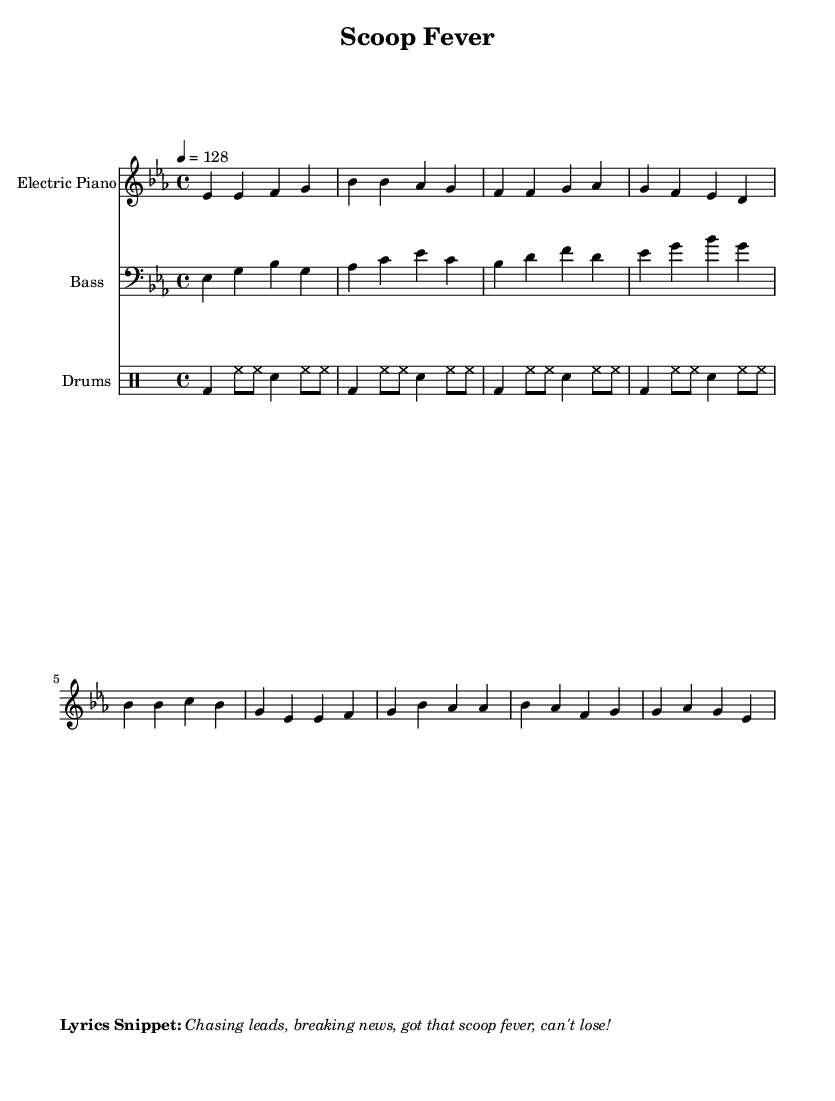What is the key signature of this music? The key signature is E-flat major, indicated by the presence of three flat symbols (B-flat, E-flat, and A-flat) at the beginning of the staff.
Answer: E-flat major What is the time signature? The time signature is 4/4, which can be identified by the '4' on top of the '4' in the staff notation. This means there are four beats in each measure and the quarter note gets one beat.
Answer: 4/4 What is the tempo marking for this piece? The tempo marking is provided as a number, indicating the speed at which the piece should be played. In this case, it specifies 128 beats per minute, indicated by '4 = 128' following the tempo indication.
Answer: 128 How many measures are in the verse section? The verse section consists of four measures, which can be counted by observing the distinct groups of notes and their assembly in the notated score. Each group, separated by vertical lines, counts as one measure.
Answer: 4 What rhythmic pattern do the drums follow? The drums follow a basic rock pattern often seen in disco music, with a bass drum on the downbeats and snare accents on the backbeats, as evident from the written drum notation.
Answer: Bass snare pattern Which instrument is primarily carrying the melody? The electric piano carries the primary melody in this piece, as indicated by the top staff in the score that shows the treble clef and contains the most prominent melodic material.
Answer: Electric piano What is the sentiment expressed in the lyrics snippet? The sentiment expressed in the lyrics snippet shows a sense of urgency and excitement related to journalism, captured in the phrase "Chasing leads, breaking news," which indicates a feeling of enthusiasm and determination in pursuit of information.
Answer: Excitement 